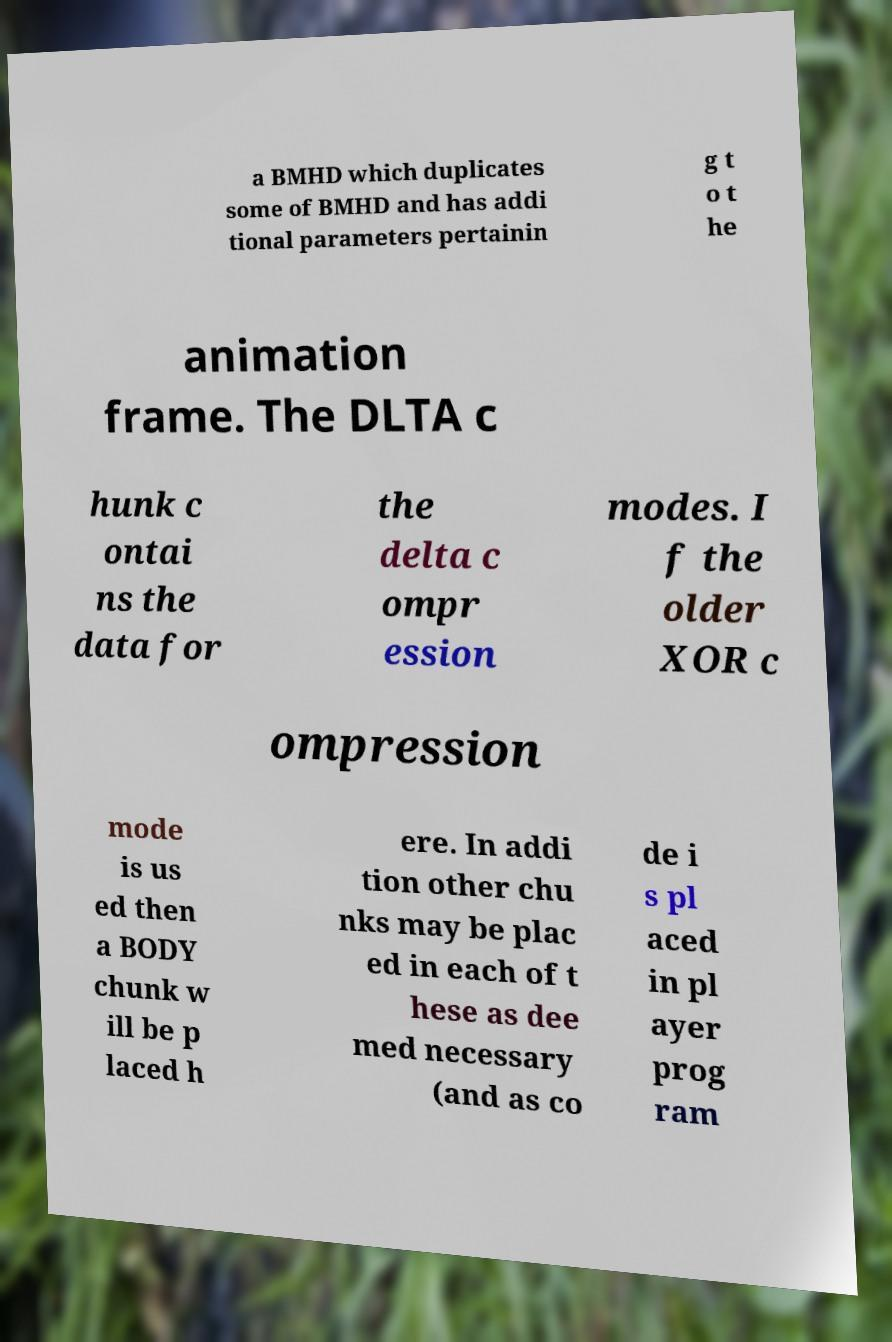Can you read and provide the text displayed in the image?This photo seems to have some interesting text. Can you extract and type it out for me? a BMHD which duplicates some of BMHD and has addi tional parameters pertainin g t o t he animation frame. The DLTA c hunk c ontai ns the data for the delta c ompr ession modes. I f the older XOR c ompression mode is us ed then a BODY chunk w ill be p laced h ere. In addi tion other chu nks may be plac ed in each of t hese as dee med necessary (and as co de i s pl aced in pl ayer prog ram 